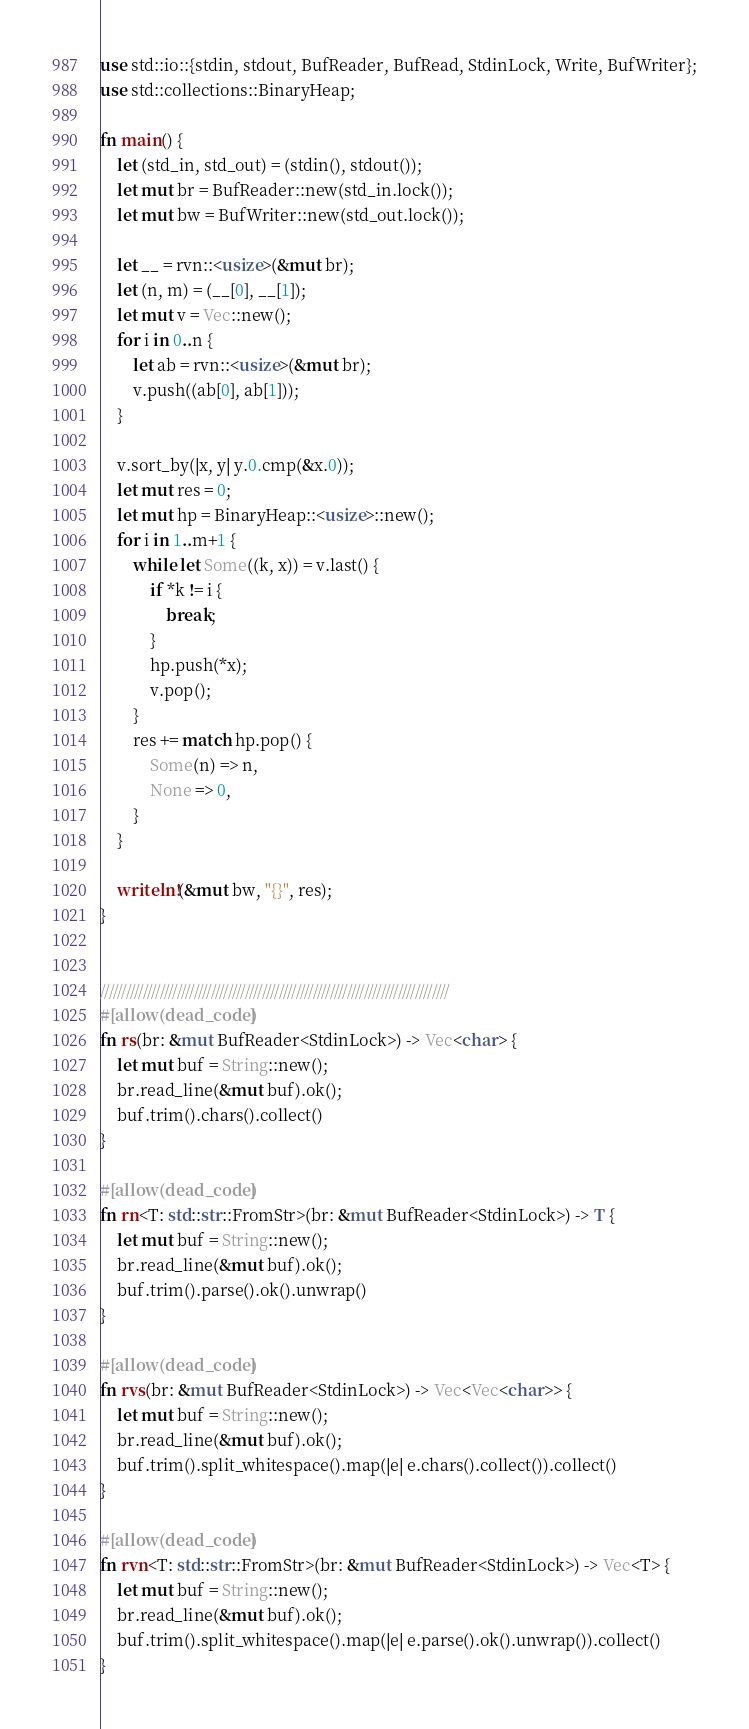Convert code to text. <code><loc_0><loc_0><loc_500><loc_500><_Rust_>use std::io::{stdin, stdout, BufReader, BufRead, StdinLock, Write, BufWriter};
use std::collections::BinaryHeap;

fn main() {
    let (std_in, std_out) = (stdin(), stdout());
    let mut br = BufReader::new(std_in.lock());
    let mut bw = BufWriter::new(std_out.lock());
    
    let __ = rvn::<usize>(&mut br);
    let (n, m) = (__[0], __[1]);
    let mut v = Vec::new();
    for i in 0..n {
        let ab = rvn::<usize>(&mut br);
        v.push((ab[0], ab[1]));
    }

    v.sort_by(|x, y| y.0.cmp(&x.0));
    let mut res = 0;
    let mut hp = BinaryHeap::<usize>::new();
    for i in 1..m+1 {
        while let Some((k, x)) = v.last() {
            if *k != i {
                break;
            }
            hp.push(*x);
            v.pop();
        }
        res += match hp.pop() {
            Some(n) => n,
            None => 0,
        }
    }
    
    writeln!(&mut bw, "{}", res);
}


//////////////////////////////////////////////////////////////////////////////////
#[allow(dead_code)]
fn rs(br: &mut BufReader<StdinLock>) -> Vec<char> {
    let mut buf = String::new();
    br.read_line(&mut buf).ok();
    buf.trim().chars().collect()
}

#[allow(dead_code)]
fn rn<T: std::str::FromStr>(br: &mut BufReader<StdinLock>) -> T {
    let mut buf = String::new();
    br.read_line(&mut buf).ok();
    buf.trim().parse().ok().unwrap()
}

#[allow(dead_code)]
fn rvs(br: &mut BufReader<StdinLock>) -> Vec<Vec<char>> {
    let mut buf = String::new();
    br.read_line(&mut buf).ok();
    buf.trim().split_whitespace().map(|e| e.chars().collect()).collect()
}

#[allow(dead_code)]
fn rvn<T: std::str::FromStr>(br: &mut BufReader<StdinLock>) -> Vec<T> {
    let mut buf = String::new();
    br.read_line(&mut buf).ok();
    buf.trim().split_whitespace().map(|e| e.parse().ok().unwrap()).collect()
}</code> 